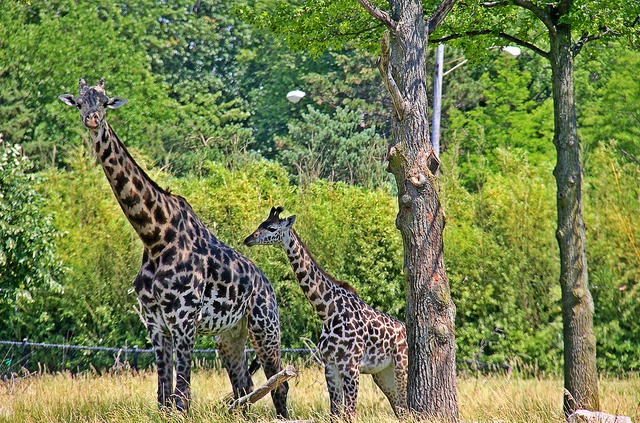Describe the objects in this image and their specific colors. I can see giraffe in olive, black, gray, darkgray, and darkgreen tones and giraffe in olive, black, gray, darkgray, and lightgray tones in this image. 